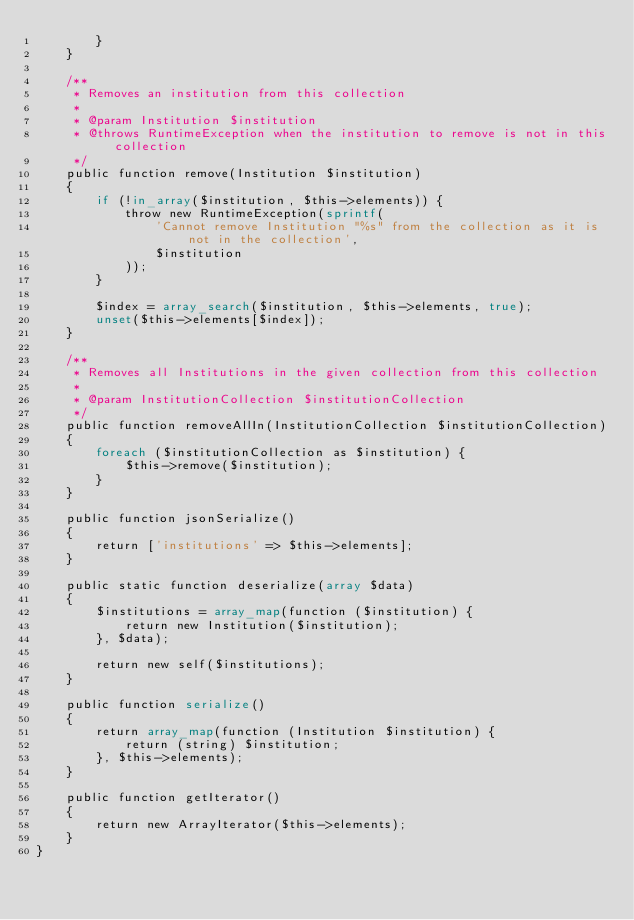Convert code to text. <code><loc_0><loc_0><loc_500><loc_500><_PHP_>        }
    }

    /**
     * Removes an institution from this collection
     *
     * @param Institution $institution
     * @throws RuntimeException when the institution to remove is not in this collection
     */
    public function remove(Institution $institution)
    {
        if (!in_array($institution, $this->elements)) {
            throw new RuntimeException(sprintf(
                'Cannot remove Institution "%s" from the collection as it is not in the collection',
                $institution
            ));
        }

        $index = array_search($institution, $this->elements, true);
        unset($this->elements[$index]);
    }

    /**
     * Removes all Institutions in the given collection from this collection
     *
     * @param InstitutionCollection $institutionCollection
     */
    public function removeAllIn(InstitutionCollection $institutionCollection)
    {
        foreach ($institutionCollection as $institution) {
            $this->remove($institution);
        }
    }

    public function jsonSerialize()
    {
        return ['institutions' => $this->elements];
    }

    public static function deserialize(array $data)
    {
        $institutions = array_map(function ($institution) {
            return new Institution($institution);
        }, $data);

        return new self($institutions);
    }

    public function serialize()
    {
        return array_map(function (Institution $institution) {
            return (string) $institution;
        }, $this->elements);
    }

    public function getIterator()
    {
        return new ArrayIterator($this->elements);
    }
}
</code> 